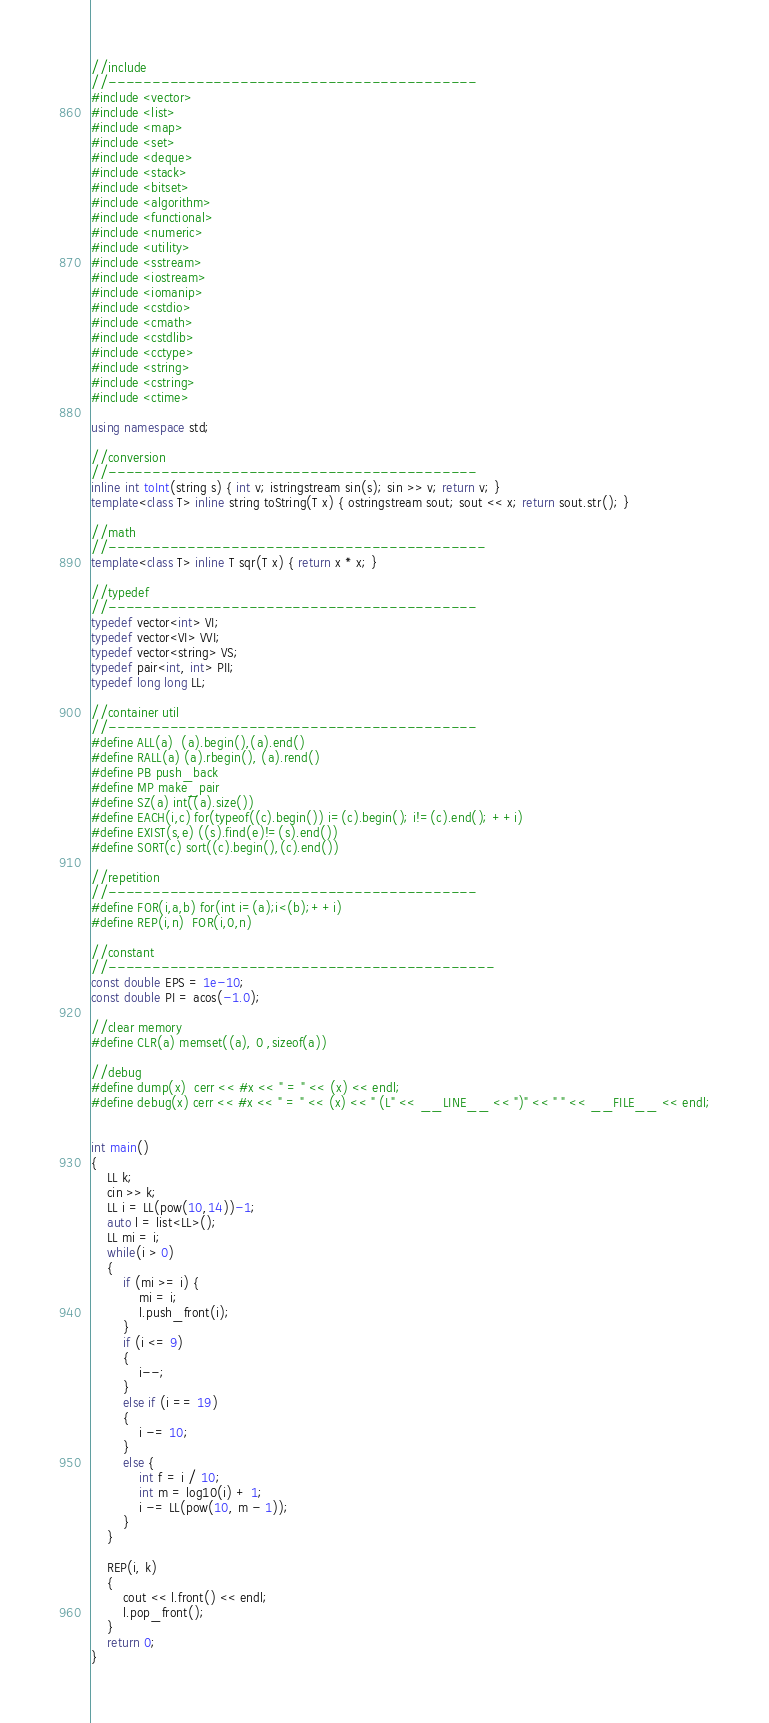<code> <loc_0><loc_0><loc_500><loc_500><_C++_>//include
//------------------------------------------
#include <vector>
#include <list>
#include <map>
#include <set>
#include <deque>
#include <stack>
#include <bitset>
#include <algorithm>
#include <functional>
#include <numeric>
#include <utility>
#include <sstream>
#include <iostream>
#include <iomanip>
#include <cstdio>
#include <cmath>
#include <cstdlib>
#include <cctype>
#include <string>
#include <cstring>
#include <ctime>

using namespace std;

//conversion
//------------------------------------------
inline int toInt(string s) { int v; istringstream sin(s); sin >> v; return v; }
template<class T> inline string toString(T x) { ostringstream sout; sout << x; return sout.str(); }

//math
//-------------------------------------------
template<class T> inline T sqr(T x) { return x * x; }

//typedef
//------------------------------------------
typedef vector<int> VI;
typedef vector<VI> VVI;
typedef vector<string> VS;
typedef pair<int, int> PII;
typedef long long LL;

//container util
//------------------------------------------
#define ALL(a)  (a).begin(),(a).end()
#define RALL(a) (a).rbegin(), (a).rend()
#define PB push_back
#define MP make_pair
#define SZ(a) int((a).size())
#define EACH(i,c) for(typeof((c).begin()) i=(c).begin(); i!=(c).end(); ++i)
#define EXIST(s,e) ((s).find(e)!=(s).end())
#define SORT(c) sort((c).begin(),(c).end())

//repetition
//------------------------------------------
#define FOR(i,a,b) for(int i=(a);i<(b);++i)
#define REP(i,n)  FOR(i,0,n)

//constant
//--------------------------------------------
const double EPS = 1e-10;
const double PI = acos(-1.0);

//clear memory
#define CLR(a) memset((a), 0 ,sizeof(a))

//debug
#define dump(x)  cerr << #x << " = " << (x) << endl;
#define debug(x) cerr << #x << " = " << (x) << " (L" << __LINE__ << ")" << " " << __FILE__ << endl;


int main()
{
	LL k;
	cin >> k;
	LL i = LL(pow(10,14))-1;
	auto l = list<LL>();
	LL mi = i;
	while(i > 0)
	{
		if (mi >= i) {
			mi = i;
			l.push_front(i);
		}
		if (i <= 9)
		{
			i--;
		}
		else if (i == 19)
		{
			i -= 10;
		}
		else {
			int f = i / 10;
			int m = log10(i) + 1;
			i -= LL(pow(10, m - 1));
		}
	}

	REP(i, k)
	{
		cout << l.front() << endl;
		l.pop_front();
	}
	return 0;
}

</code> 